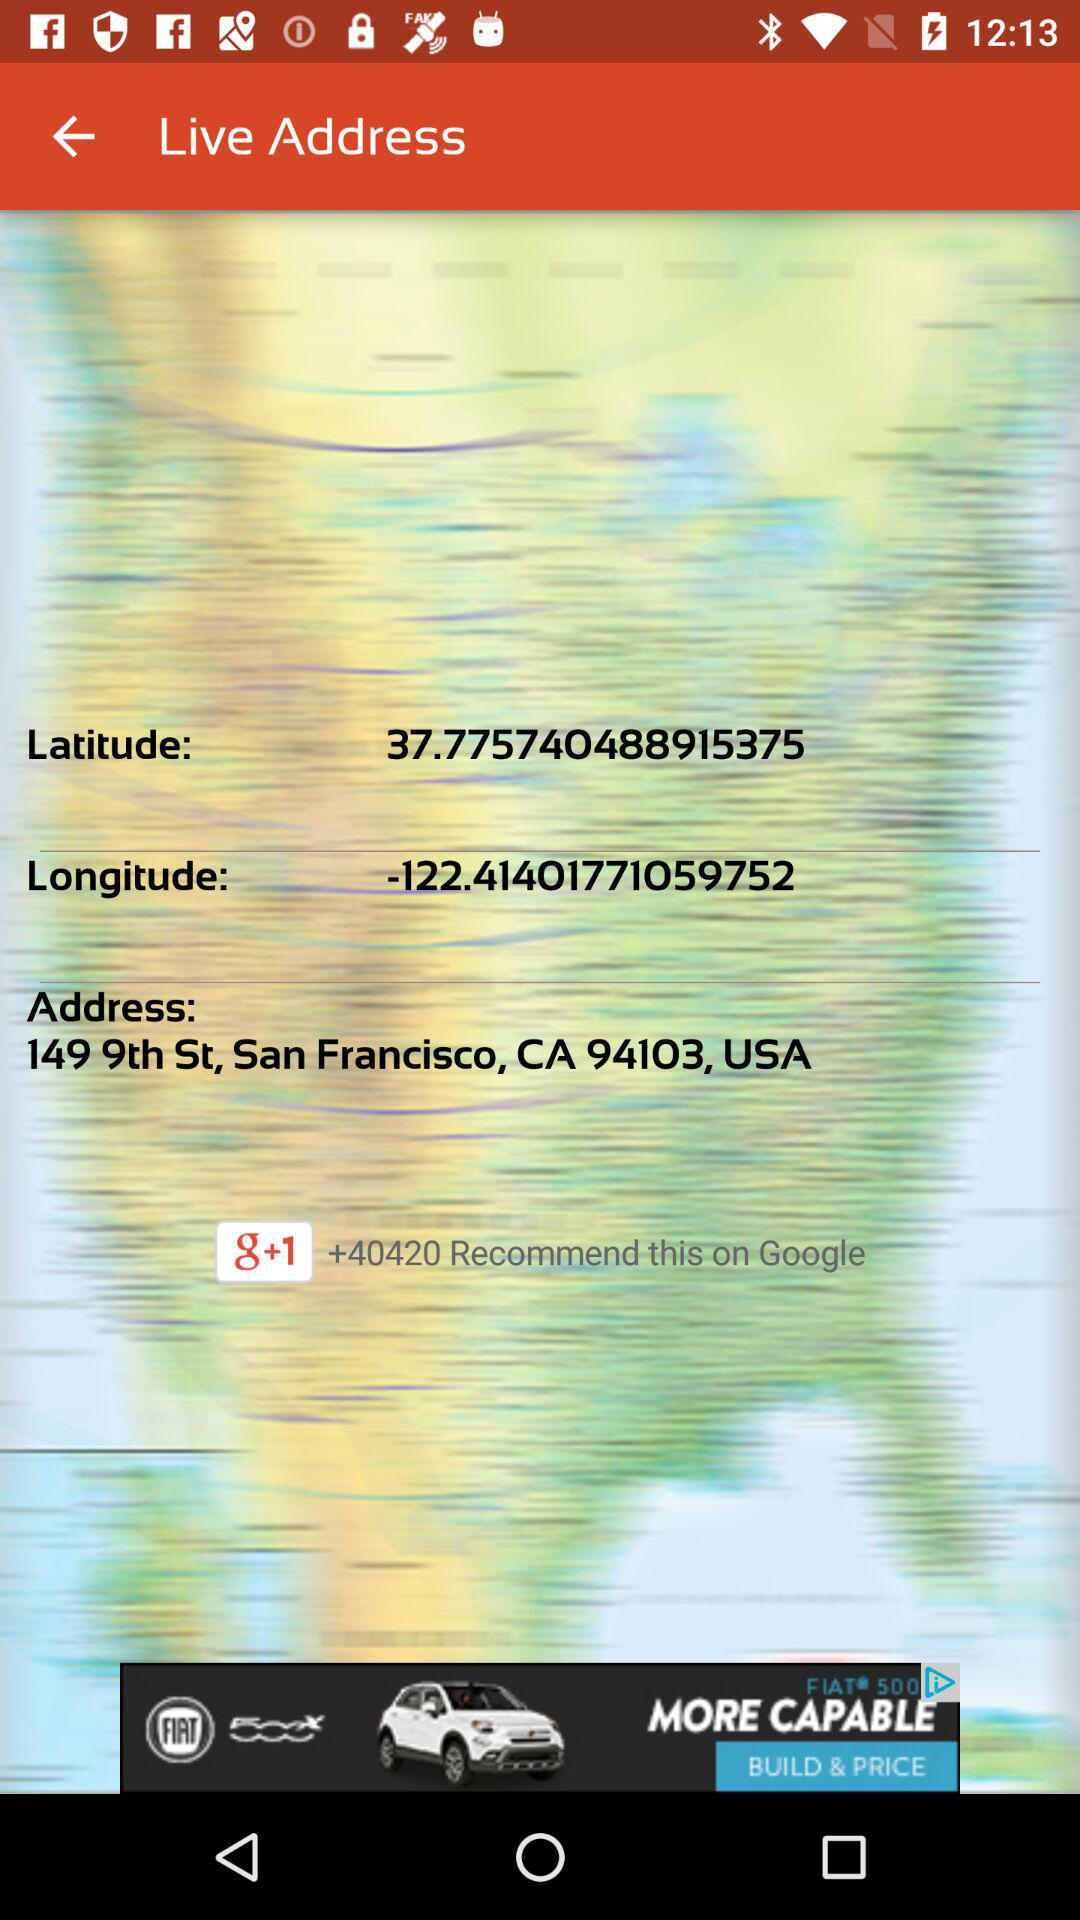How many recommendations are on "Google"? There are more than 40420 recommendations on "Google". 